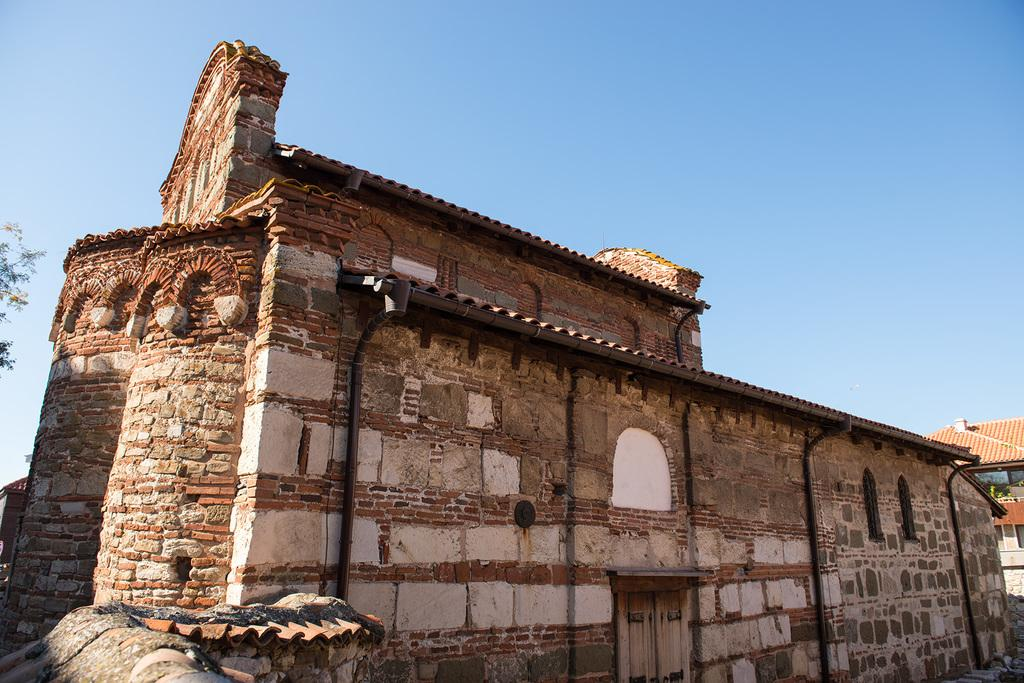What type of structure is depicted in the image? There is a building in the image that resembles a fort. Are there any other structures near the fort-like building? Yes, there is a house beside the fort-like building. What is the temperature inside the fort-like building in the image? The provided facts do not mention the temperature inside the building, so we cannot determine the temperature from the image. 